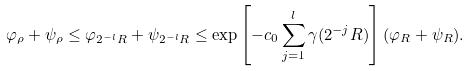<formula> <loc_0><loc_0><loc_500><loc_500>\varphi _ { \rho } + \psi _ { \rho } \leq \varphi _ { 2 ^ { - l } R } + \psi _ { 2 ^ { - l } R } \leq \exp \left [ - c _ { 0 } \sum _ { j = 1 } ^ { l } \gamma ( 2 ^ { - j } R ) \right ] ( \varphi _ { R } + \psi _ { R } ) .</formula> 